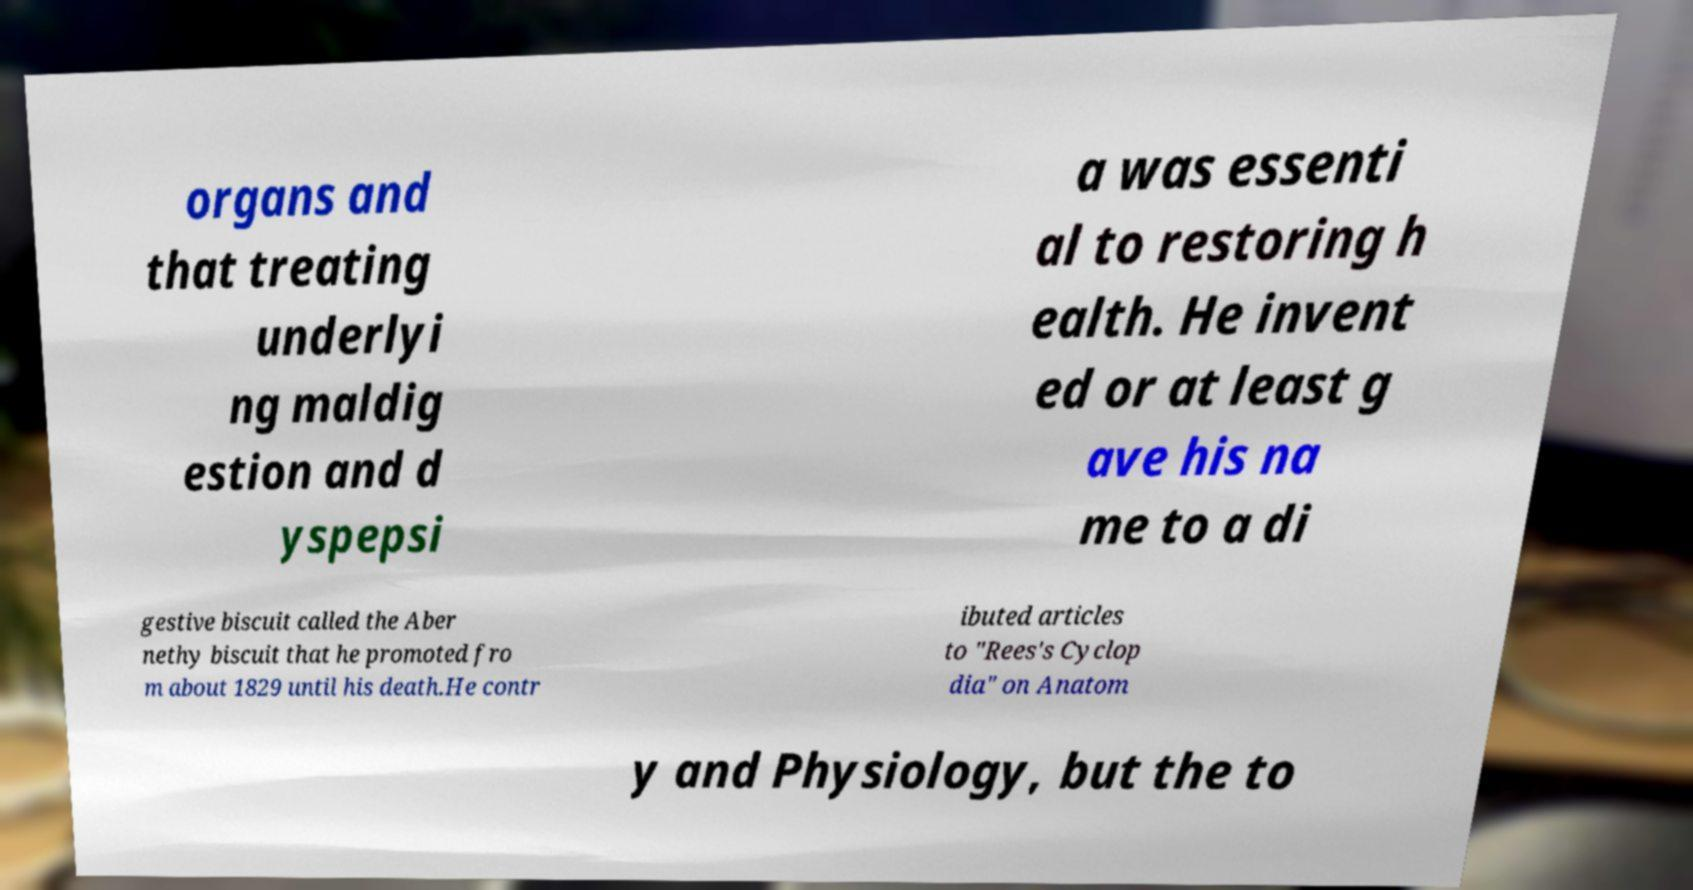Could you extract and type out the text from this image? organs and that treating underlyi ng maldig estion and d yspepsi a was essenti al to restoring h ealth. He invent ed or at least g ave his na me to a di gestive biscuit called the Aber nethy biscuit that he promoted fro m about 1829 until his death.He contr ibuted articles to "Rees's Cyclop dia" on Anatom y and Physiology, but the to 